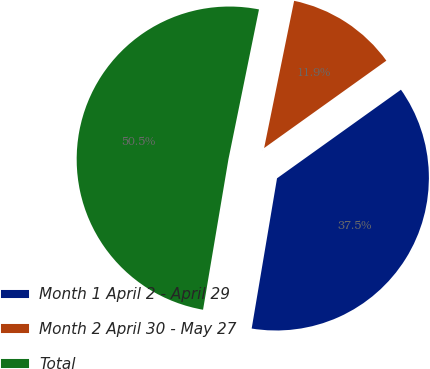Convert chart to OTSL. <chart><loc_0><loc_0><loc_500><loc_500><pie_chart><fcel>Month 1 April 2 - April 29<fcel>Month 2 April 30 - May 27<fcel>Total<nl><fcel>37.54%<fcel>11.92%<fcel>50.54%<nl></chart> 